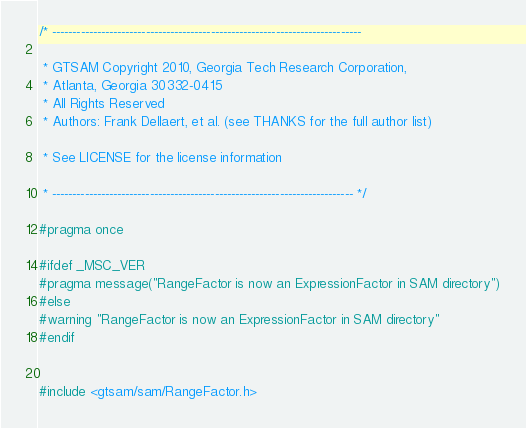<code> <loc_0><loc_0><loc_500><loc_500><_C_>/* ----------------------------------------------------------------------------

 * GTSAM Copyright 2010, Georgia Tech Research Corporation, 
 * Atlanta, Georgia 30332-0415
 * All Rights Reserved
 * Authors: Frank Dellaert, et al. (see THANKS for the full author list)

 * See LICENSE for the license information

 * -------------------------------------------------------------------------- */

#pragma once

#ifdef _MSC_VER
#pragma message("RangeFactor is now an ExpressionFactor in SAM directory")
#else
#warning "RangeFactor is now an ExpressionFactor in SAM directory"
#endif


#include <gtsam/sam/RangeFactor.h>

</code> 